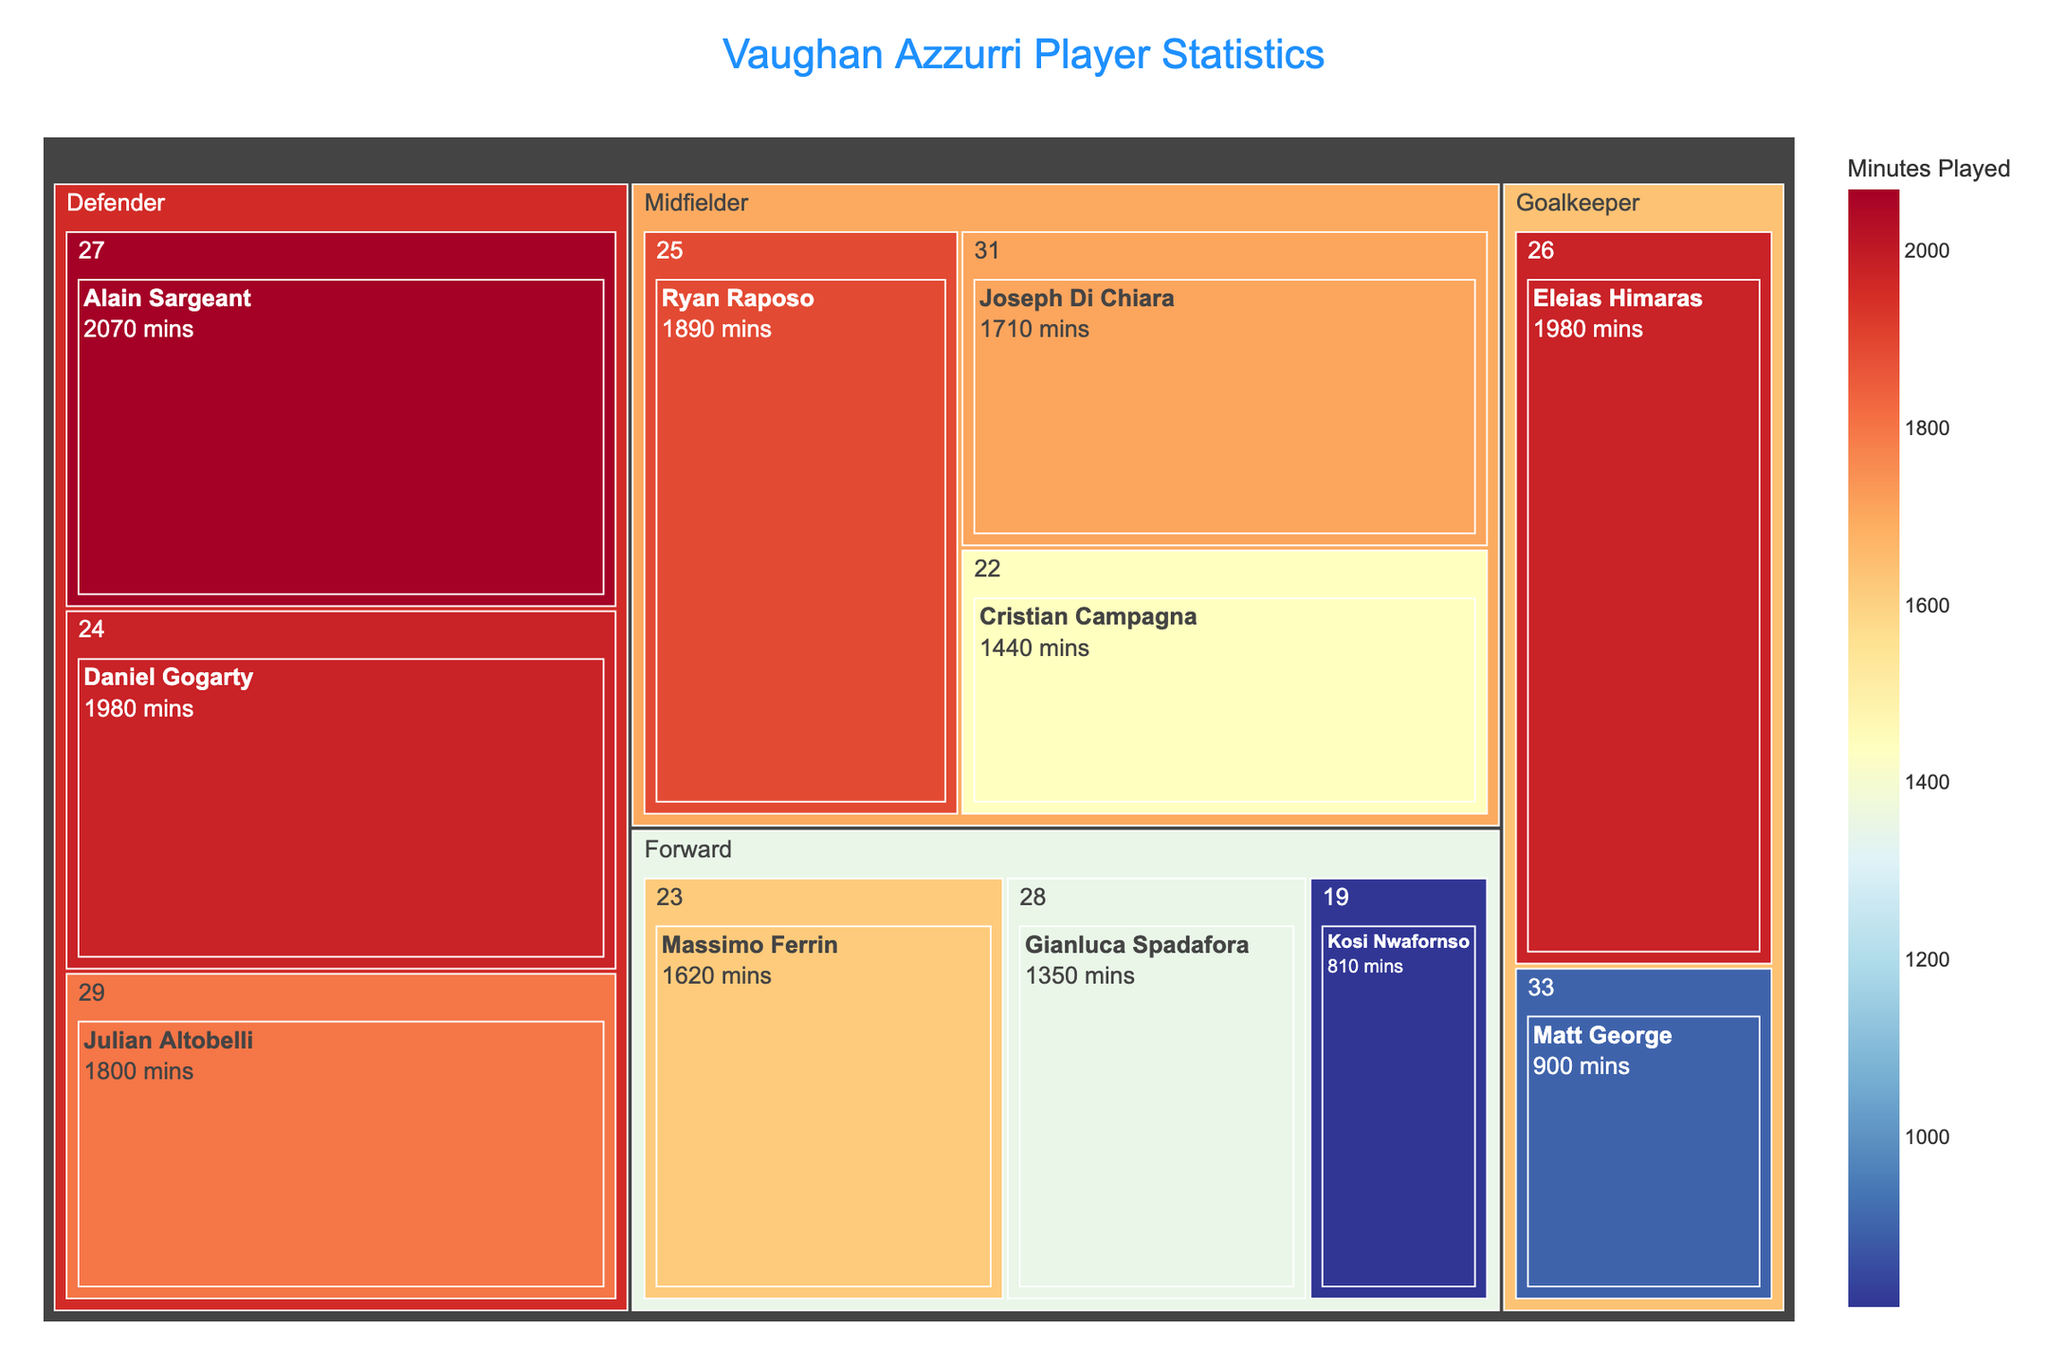What's the title of the plot? The title of the plot is prominently displayed at the top, as per the layout settings in `update_layout`.
Answer: Vaughan Azzurri Player Statistics Which player has played the most minutes among the defenders? The treemap is color-coded and sized according to the minutes played, helping to easily identify the player with the largest area and the darkest color among defenders.
Answer: Alain Sargeant How many players are in the midfield position? Each position is broken down in the treemap, and the number of boxes under the "Midfielder" category will give this count.
Answer: 3 What's the total playing time for all forwards? Sum up the "Minutes Played" for Massimo Ferrin, Gianluca Spadafora, and Kosi Nwafornso. That’s 1620 + 1350 + 810 = 3780 minutes.
Answer: 3780 Which age group has the player with the least minutes played? Compare the smallest box sizes and their respective age groups. Matt George, aged 33, played for 900 minutes, making his the smallest box.
Answer: 33 Who is the oldest player, and how many minutes did he play? The treemap organizes by age within each position, allowing easy identification. The oldest player is Matt George, aged 33, with 900 minutes played.
Answer: Matt George, 900 minutes What's the difference in minutes played between the goalkeeper with the most minutes and the one with the least? Subtract the minutes of the goalkeeper with the least minutes (Matt George, 900) from the one with the most (Eleias Himaras, 1980). That’s 1980 - 900.
Answer: 1080 How does Ryan Raposo's playing time compare to Julian Altobelli's? Check the boxes for both players. Ryan Raposo (1890 minutes) has a larger box and darker color compared to Julian Altobelli (1800 minutes).
Answer: More What's the average playing time of all the players aged 25 and above? Calculate the total playing time for players aged 25 and above and then divide by the number of these players. Total is 1890 (Ryan Raposo) + 1710 (Joseph Di Chiara) + 2070 (Alain Sargeant) + 1980 (Daniel Gogarty) + 1800 (Julian Altobelli) + 1980 (Eleias Himaras) + 900 (Matt George) = 12330 minutes. Number of players is 7. Average is 12330/7.
Answer: 1761.43 Which position has the lowest playing time overall? Sum up the "Minutes Played" for each position and find the smallest total. For goalkeepers: 1980 (Eleias Himaras) + 900 (Matt George) = 2880 minutes. Sum for other positions will be higher.
Answer: Goalkeeper 